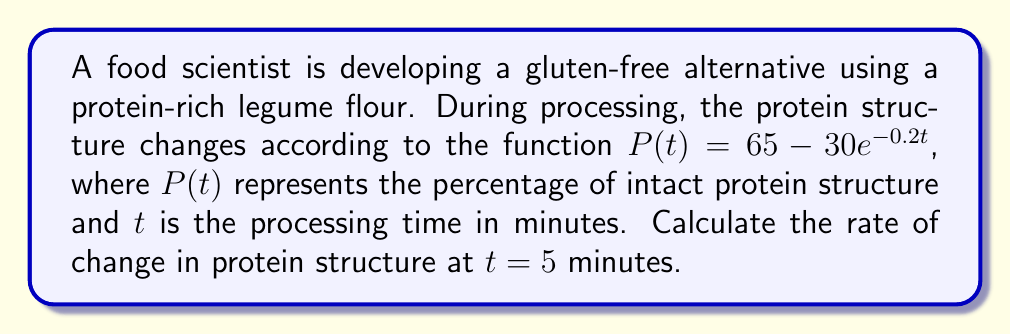Could you help me with this problem? To find the rate of change in protein structure at $t = 5$ minutes, we need to calculate the derivative of the function $P(t)$ and evaluate it at $t = 5$.

Step 1: Express the given function.
$$P(t) = 65 - 30e^{-0.2t}$$

Step 2: Calculate the derivative of $P(t)$ with respect to $t$.
$$\frac{dP}{dt} = -30 \cdot (-0.2)e^{-0.2t} = 6e^{-0.2t}$$

Step 3: Evaluate the derivative at $t = 5$.
$$\left.\frac{dP}{dt}\right|_{t=5} = 6e^{-0.2(5)} = 6e^{-1} \approx 2.21$$

The rate of change is positive, indicating that the percentage of intact protein structure is increasing at $t = 5$ minutes.
Answer: $2.21\%$ per minute 